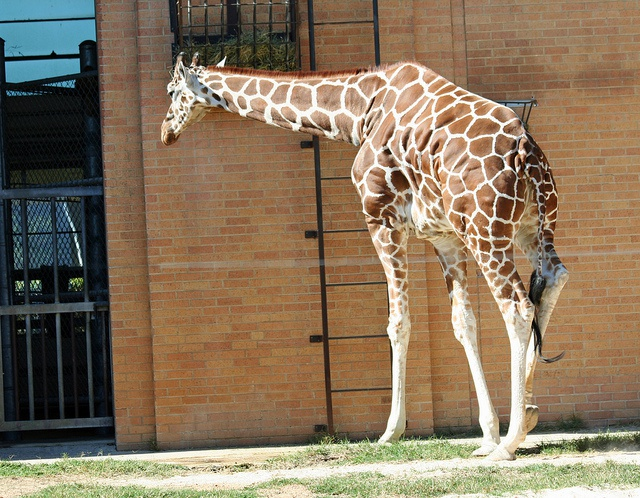Describe the objects in this image and their specific colors. I can see a giraffe in lightblue, ivory, gray, and tan tones in this image. 